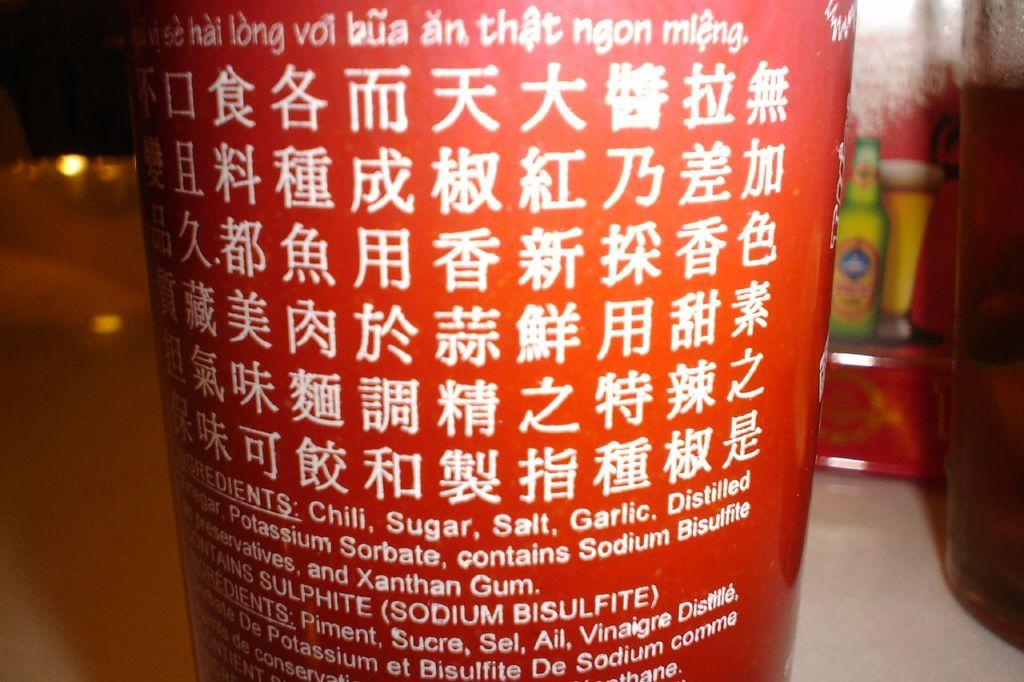<image>
Relay a brief, clear account of the picture shown. red cup with asian writing and ingredients starting with chili, sugar, salt, and garlic 